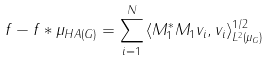Convert formula to latex. <formula><loc_0><loc_0><loc_500><loc_500>\| f - f \ast \mu _ { H } \| _ { A ( G ) } = \sum _ { i = 1 } ^ { N } { \langle M _ { 1 } ^ { * } M _ { 1 } v _ { i } , v _ { i } \rangle _ { L ^ { 2 } ( \mu _ { G } ) } ^ { 1 / 2 } }</formula> 